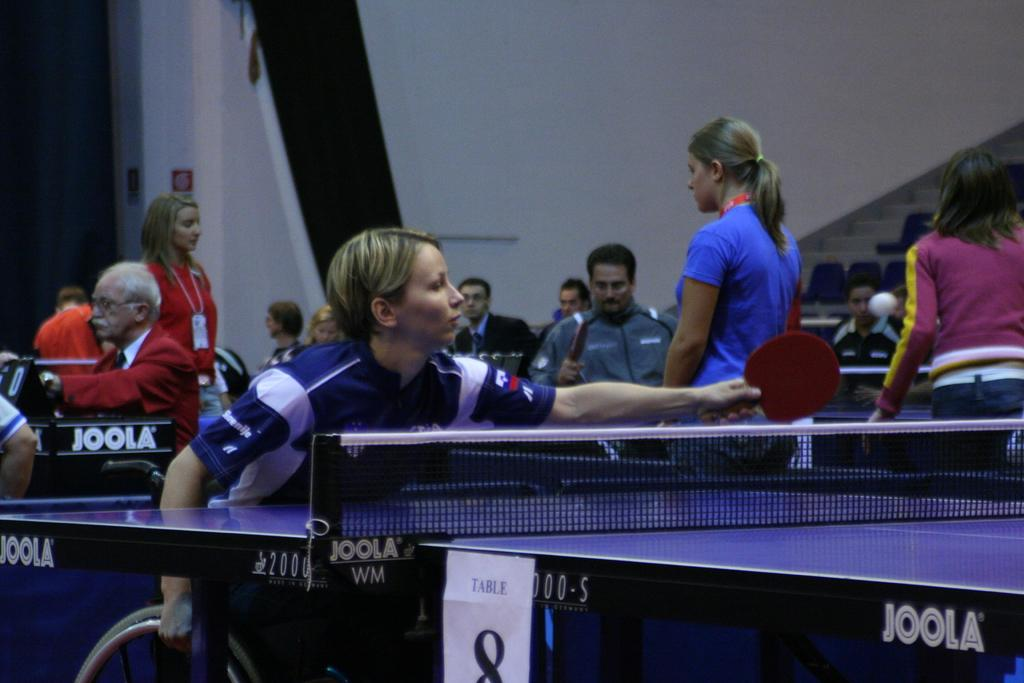What is happening in the image involving a group of people? Some people in the group are playing table tennis. Can you describe the activity taking place in the image? The activity involves playing table tennis, which is a sport that requires a table, a net, and a small ball. What type of operation is being performed in the image? There is no operation taking place in the image; it features a group of people playing table tennis. Can you describe the bedroom setting in the image? There is no bedroom setting in the image; it shows a group of people playing table tennis in a different environment. 